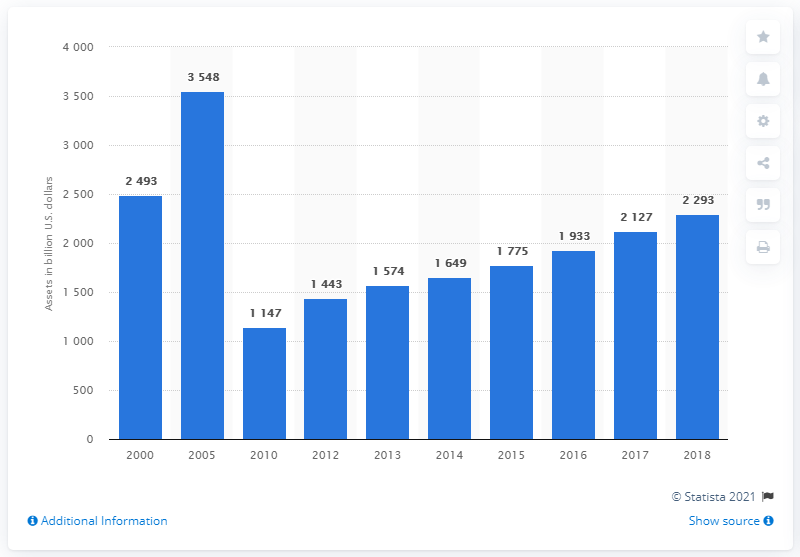List a handful of essential elements in this visual. In 2018, the financial assets of agency- and GSE-backed mortgage pools were valued at approximately 2293. 